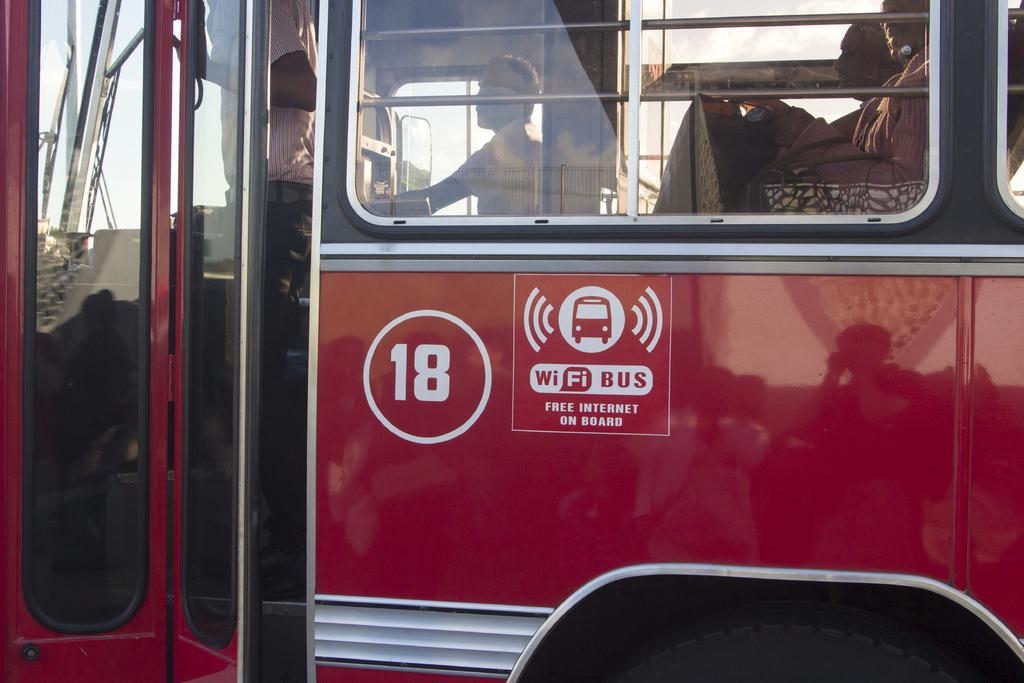What is the main subject of the image? The main subject of the image is a bus. What can be seen inside the bus? There are people sitting in the bus. Are there any people standing in the image? Yes, there is a person standing. What type of cracker is the person holding in the image? There is no cracker present in the image. How does the door of the bus open in the image? There is no door visible in the image, so it is not possible to determine how it opens. 